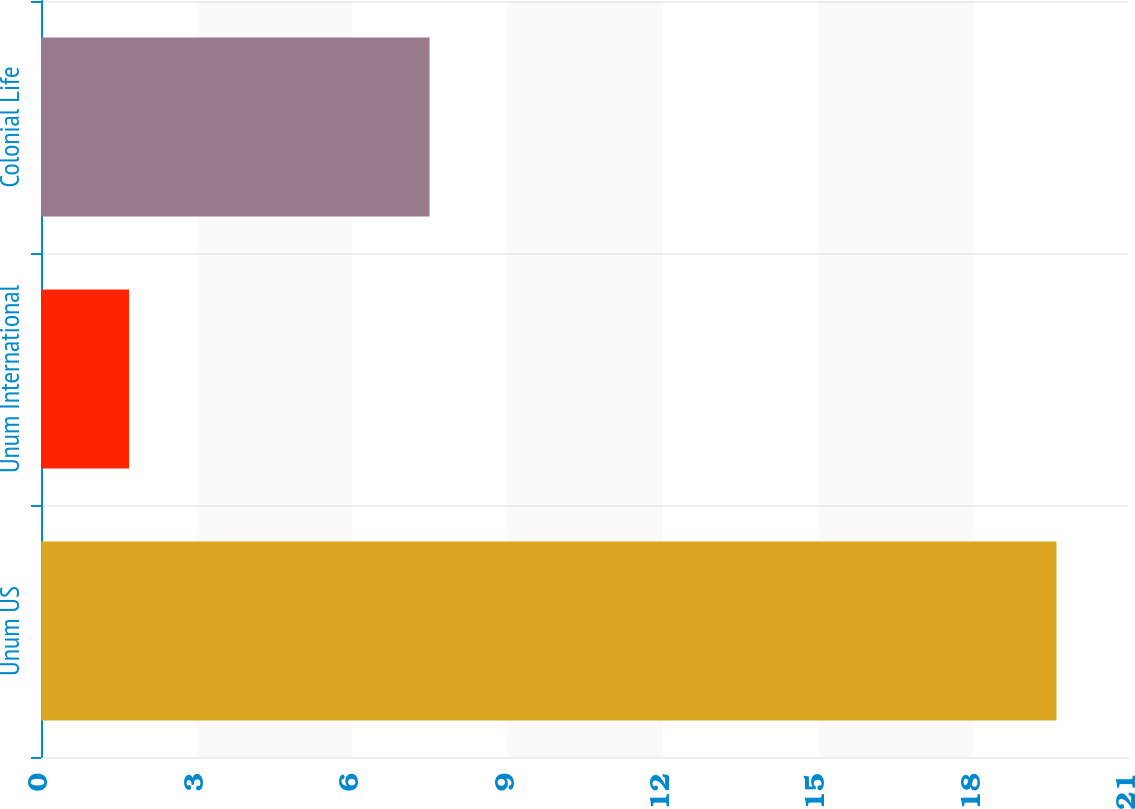Convert chart. <chart><loc_0><loc_0><loc_500><loc_500><bar_chart><fcel>Unum US<fcel>Unum International<fcel>Colonial Life<nl><fcel>19.6<fcel>1.7<fcel>7.5<nl></chart> 